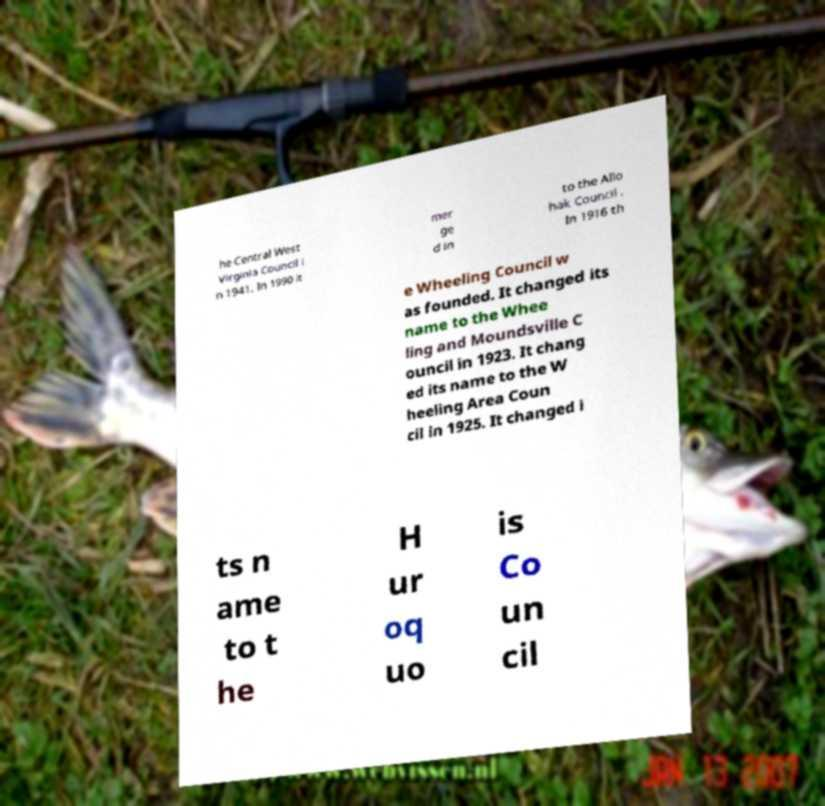Can you accurately transcribe the text from the provided image for me? he Central West Virginia Council i n 1941. In 1990 it mer ge d in to the Allo hak Council . In 1916 th e Wheeling Council w as founded. It changed its name to the Whee ling and Moundsville C ouncil in 1923. It chang ed its name to the W heeling Area Coun cil in 1925. It changed i ts n ame to t he H ur oq uo is Co un cil 